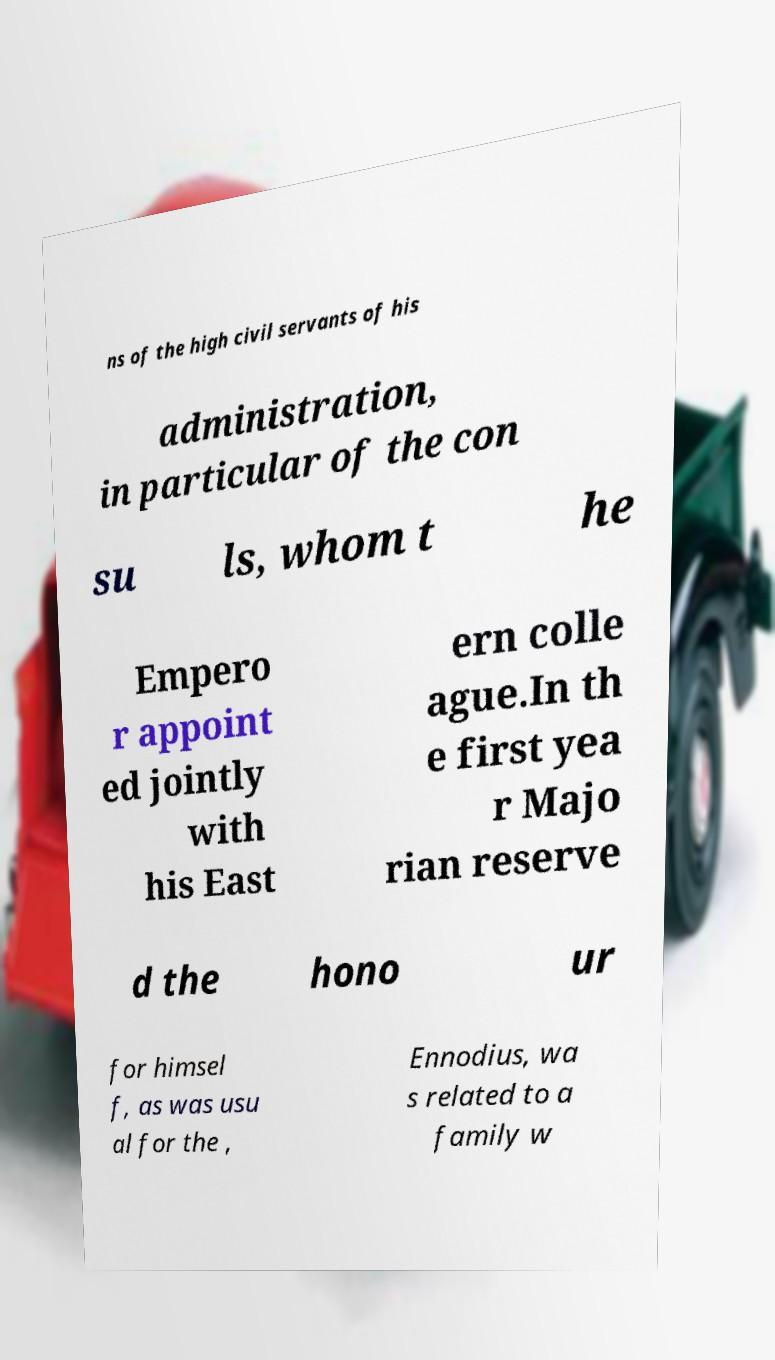Can you read and provide the text displayed in the image?This photo seems to have some interesting text. Can you extract and type it out for me? ns of the high civil servants of his administration, in particular of the con su ls, whom t he Empero r appoint ed jointly with his East ern colle ague.In th e first yea r Majo rian reserve d the hono ur for himsel f, as was usu al for the , Ennodius, wa s related to a family w 